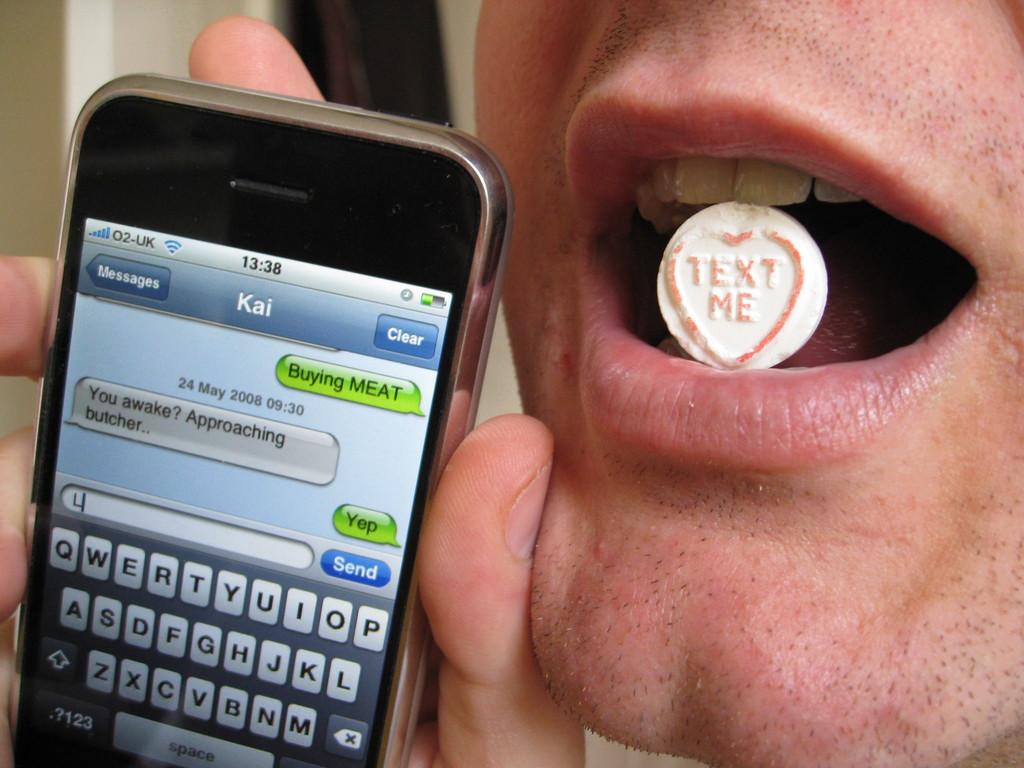What is kai buying?
Provide a short and direct response. Meat. What does the heart in his mouth say?
Keep it short and to the point. Text me. 